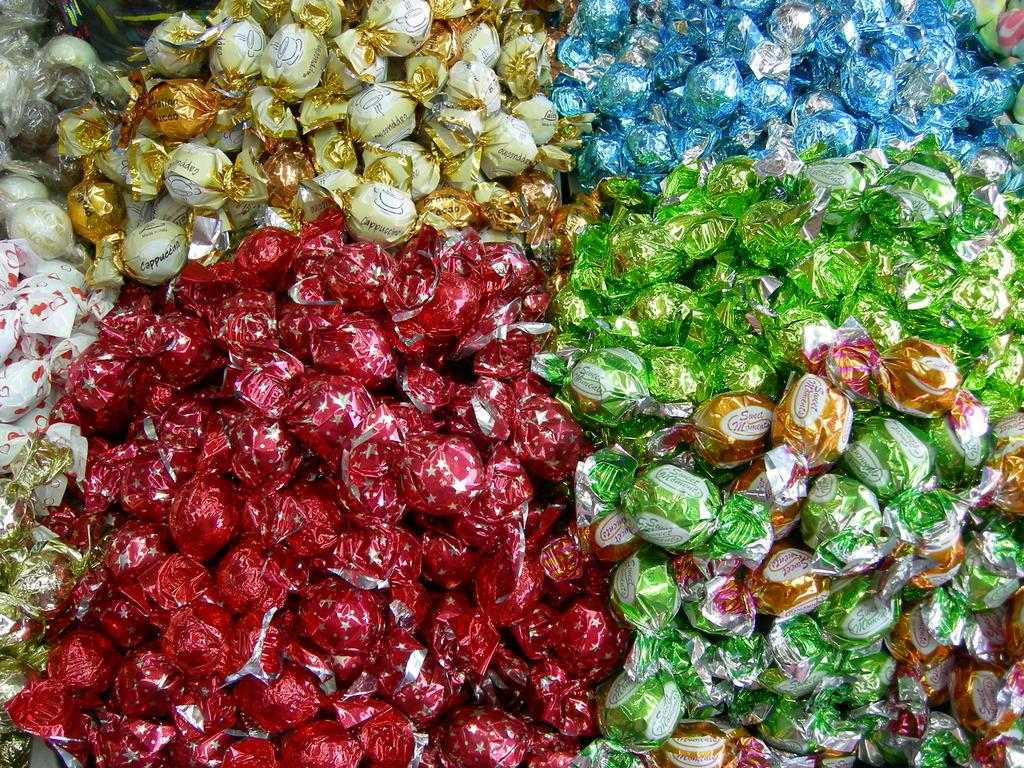What type of food can be seen in the image? There are chocolates in the image. What can be observed about the wrappers of the chocolates? The wrappers of the chocolates have various colors, including green, blue, red, gold, and white. Can you see any veins in the chocolates in the image? There are no visible veins in the chocolates in the image, as chocolates do not have veins. 